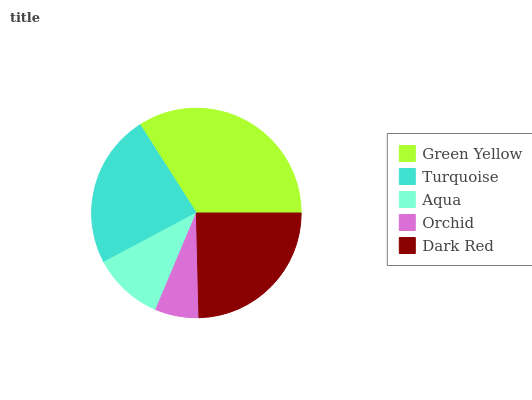Is Orchid the minimum?
Answer yes or no. Yes. Is Green Yellow the maximum?
Answer yes or no. Yes. Is Turquoise the minimum?
Answer yes or no. No. Is Turquoise the maximum?
Answer yes or no. No. Is Green Yellow greater than Turquoise?
Answer yes or no. Yes. Is Turquoise less than Green Yellow?
Answer yes or no. Yes. Is Turquoise greater than Green Yellow?
Answer yes or no. No. Is Green Yellow less than Turquoise?
Answer yes or no. No. Is Turquoise the high median?
Answer yes or no. Yes. Is Turquoise the low median?
Answer yes or no. Yes. Is Aqua the high median?
Answer yes or no. No. Is Dark Red the low median?
Answer yes or no. No. 